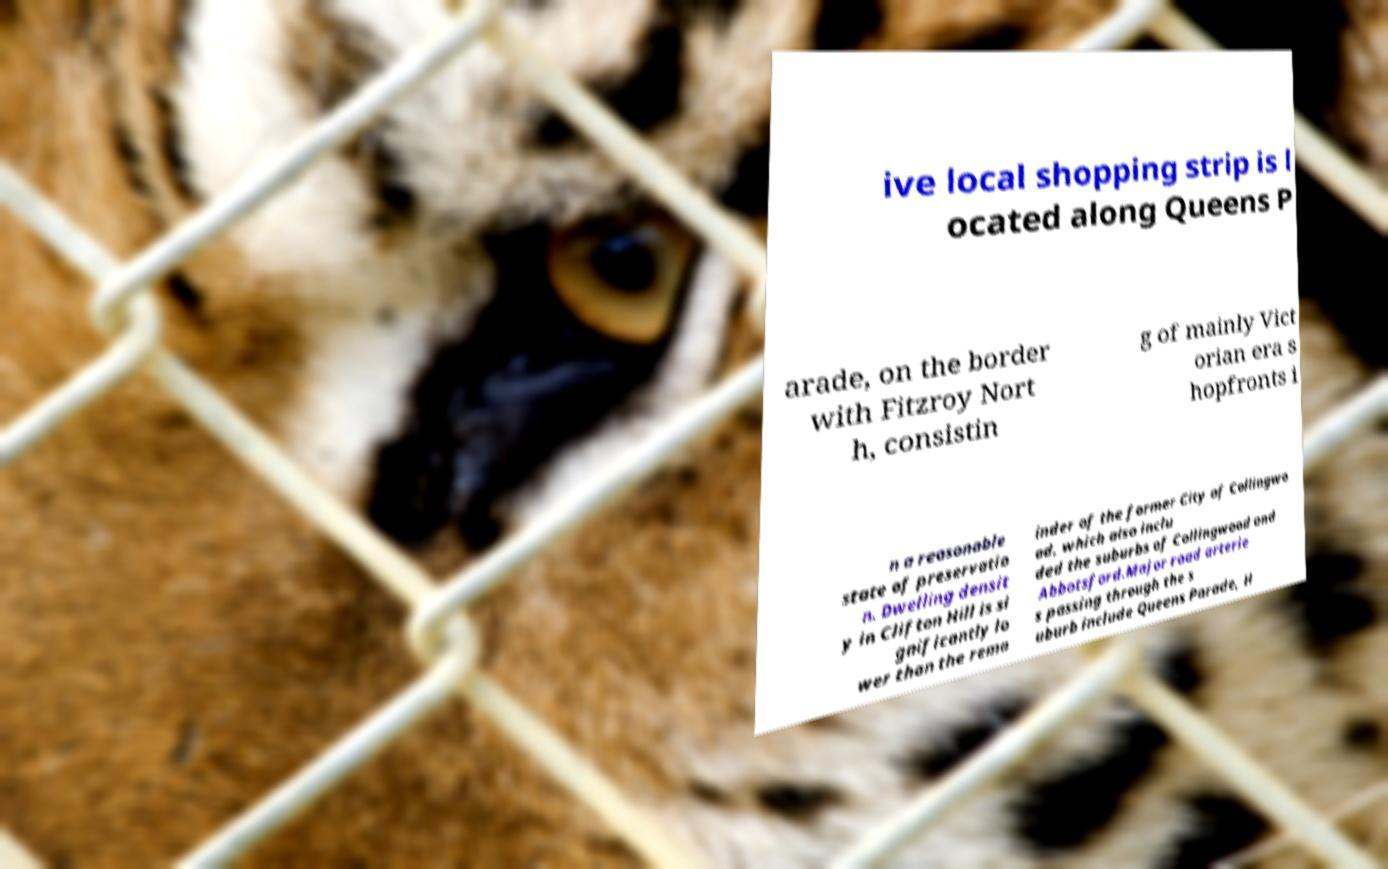There's text embedded in this image that I need extracted. Can you transcribe it verbatim? ive local shopping strip is l ocated along Queens P arade, on the border with Fitzroy Nort h, consistin g of mainly Vict orian era s hopfronts i n a reasonable state of preservatio n. Dwelling densit y in Clifton Hill is si gnificantly lo wer than the rema inder of the former City of Collingwo od, which also inclu ded the suburbs of Collingwood and Abbotsford.Major road arterie s passing through the s uburb include Queens Parade, H 